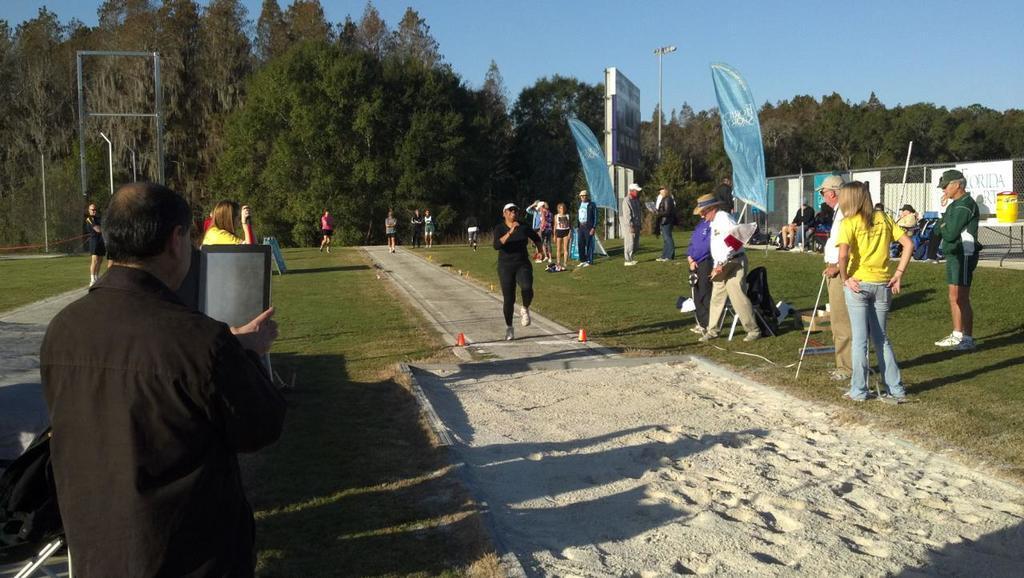Please provide a concise description of this image. There are people, this man holding a gadget and this man running. We can see bag, grass and sand. In the background we can see yellow object on the table, bags, fence, boards, banners, hoarding, light on pole, poles, trees and sky. 